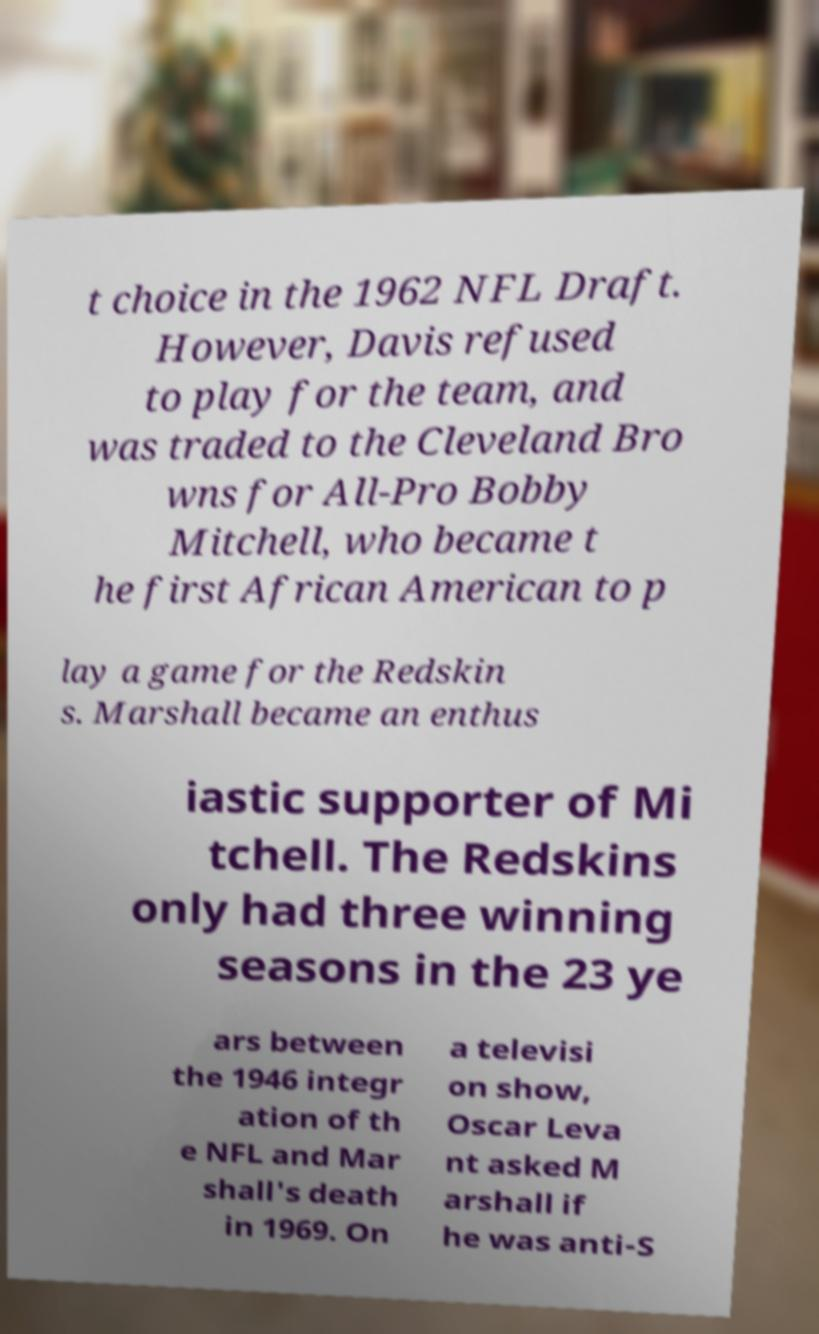Please read and relay the text visible in this image. What does it say? t choice in the 1962 NFL Draft. However, Davis refused to play for the team, and was traded to the Cleveland Bro wns for All-Pro Bobby Mitchell, who became t he first African American to p lay a game for the Redskin s. Marshall became an enthus iastic supporter of Mi tchell. The Redskins only had three winning seasons in the 23 ye ars between the 1946 integr ation of th e NFL and Mar shall's death in 1969. On a televisi on show, Oscar Leva nt asked M arshall if he was anti-S 